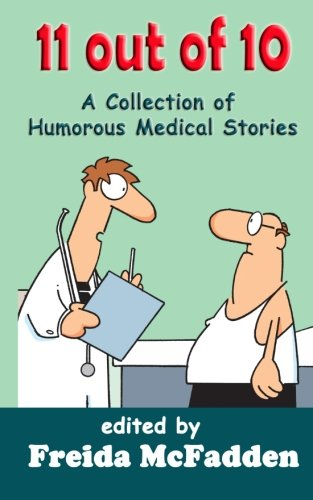Describe the scenario depicted on the cover of this book. The book cover features two characters who appear to be medical professionals. One is holding a clipboard and seems to be discussing something with the other, who looks slightly perplexed or thoughtful. This light-hearted imagery suggests humorous interactions possibly reflective of the book's content. 